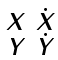<formula> <loc_0><loc_0><loc_500><loc_500>\begin{smallmatrix} X & \dot { X } \\ Y & \dot { Y } \end{smallmatrix}</formula> 